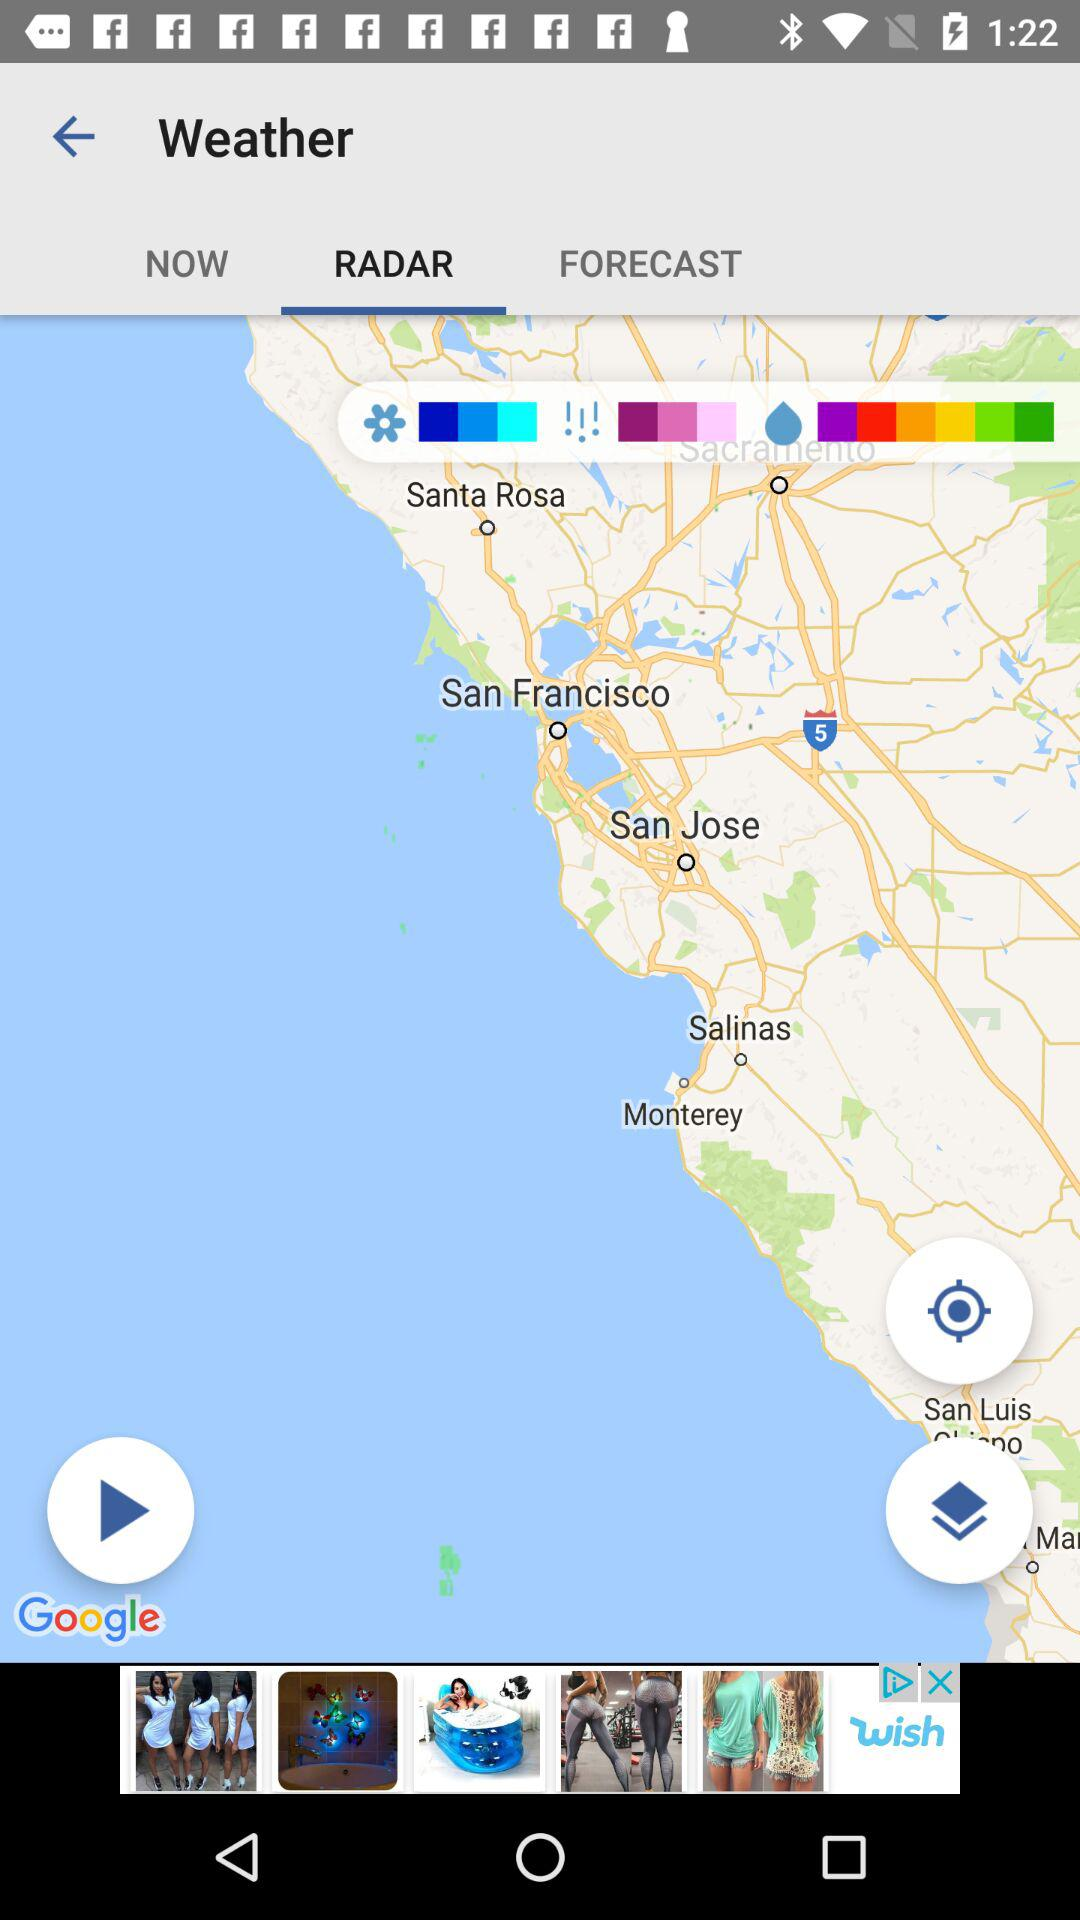How many shades of blue are there on the map?
Answer the question using a single word or phrase. 3 